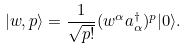<formula> <loc_0><loc_0><loc_500><loc_500>| w , p \rangle = \frac { 1 } { \sqrt { p ! } } ( w ^ { \alpha } a _ { \alpha } ^ { \dagger } ) ^ { p } | 0 \rangle .</formula> 